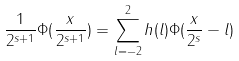Convert formula to latex. <formula><loc_0><loc_0><loc_500><loc_500>\frac { 1 } { 2 ^ { s + 1 } } \Phi ( \frac { x } { 2 ^ { s + 1 } } ) = \sum _ { l = - 2 } ^ { 2 } h ( l ) \Phi ( \frac { x } { 2 ^ { s } } - l ) \\</formula> 